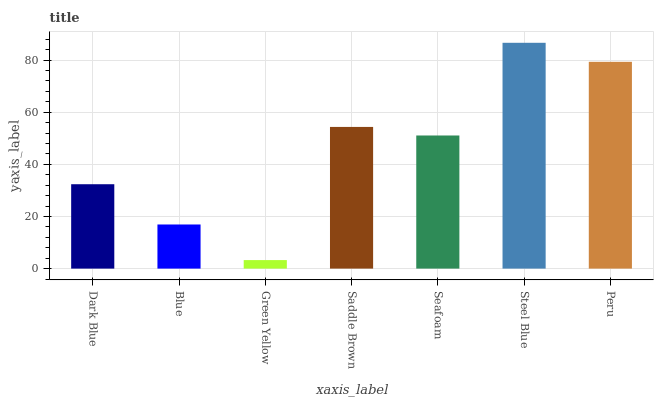Is Green Yellow the minimum?
Answer yes or no. Yes. Is Steel Blue the maximum?
Answer yes or no. Yes. Is Blue the minimum?
Answer yes or no. No. Is Blue the maximum?
Answer yes or no. No. Is Dark Blue greater than Blue?
Answer yes or no. Yes. Is Blue less than Dark Blue?
Answer yes or no. Yes. Is Blue greater than Dark Blue?
Answer yes or no. No. Is Dark Blue less than Blue?
Answer yes or no. No. Is Seafoam the high median?
Answer yes or no. Yes. Is Seafoam the low median?
Answer yes or no. Yes. Is Saddle Brown the high median?
Answer yes or no. No. Is Green Yellow the low median?
Answer yes or no. No. 